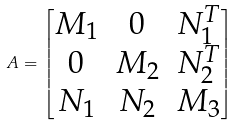<formula> <loc_0><loc_0><loc_500><loc_500>A = \left [ \begin{matrix} M _ { 1 } & 0 & N _ { 1 } ^ { T } \\ 0 & M _ { 2 } & N _ { 2 } ^ { T } \\ N _ { 1 } & N _ { 2 } & M _ { 3 } \end{matrix} \right ]</formula> 